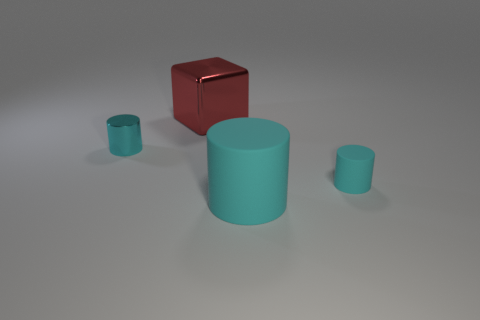The object that is the same size as the metal cylinder is what shape?
Offer a very short reply. Cylinder. Are there fewer tiny cyan metal cylinders that are on the right side of the large metallic object than green metallic things?
Offer a very short reply. No. What number of rubber cylinders have the same size as the cyan metal thing?
Provide a succinct answer. 1. What is the shape of the metal thing that is the same color as the big matte cylinder?
Offer a terse response. Cylinder. Do the cube that is behind the tiny cyan rubber cylinder and the rubber cylinder left of the tiny rubber thing have the same color?
Give a very brief answer. No. There is a big shiny object; how many red things are left of it?
Your answer should be very brief. 0. There is another matte cylinder that is the same color as the tiny matte cylinder; what size is it?
Make the answer very short. Large. Is there another green object of the same shape as the small shiny thing?
Ensure brevity in your answer.  No. What is the color of the thing that is the same size as the metallic cylinder?
Offer a terse response. Cyan. Is the number of big matte cylinders in front of the big rubber thing less than the number of tiny matte cylinders that are to the left of the red object?
Make the answer very short. No. 